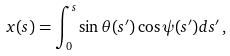Convert formula to latex. <formula><loc_0><loc_0><loc_500><loc_500>x ( s ) = \int ^ { s } _ { 0 } \sin \theta ( s ^ { \prime } ) \cos \psi ( s ^ { \prime } ) d s ^ { \prime } \, ,</formula> 